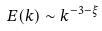<formula> <loc_0><loc_0><loc_500><loc_500>E ( k ) \sim k ^ { - 3 - \xi }</formula> 